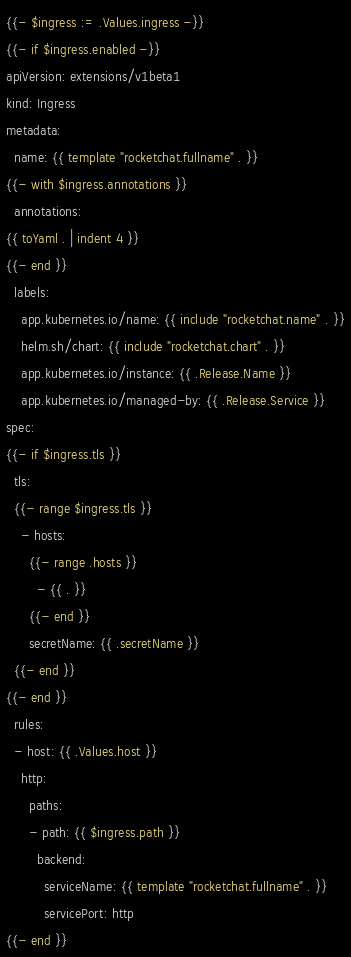Convert code to text. <code><loc_0><loc_0><loc_500><loc_500><_YAML_>{{- $ingress := .Values.ingress -}}
{{- if $ingress.enabled -}}
apiVersion: extensions/v1beta1
kind: Ingress
metadata:
  name: {{ template "rocketchat.fullname" . }}
{{- with $ingress.annotations }}
  annotations:
{{ toYaml . | indent 4 }}
{{- end }}
  labels:
    app.kubernetes.io/name: {{ include "rocketchat.name" . }}
    helm.sh/chart: {{ include "rocketchat.chart" . }}
    app.kubernetes.io/instance: {{ .Release.Name }}
    app.kubernetes.io/managed-by: {{ .Release.Service }}
spec:
{{- if $ingress.tls }}
  tls:
  {{- range $ingress.tls }}
    - hosts:
      {{- range .hosts }}
        - {{ . }}
      {{- end }}
      secretName: {{ .secretName }}
  {{- end }}
{{- end }}
  rules:
  - host: {{ .Values.host }}
    http:
      paths:
      - path: {{ $ingress.path }}
        backend:
          serviceName: {{ template "rocketchat.fullname" . }}
          servicePort: http
{{- end }}
</code> 